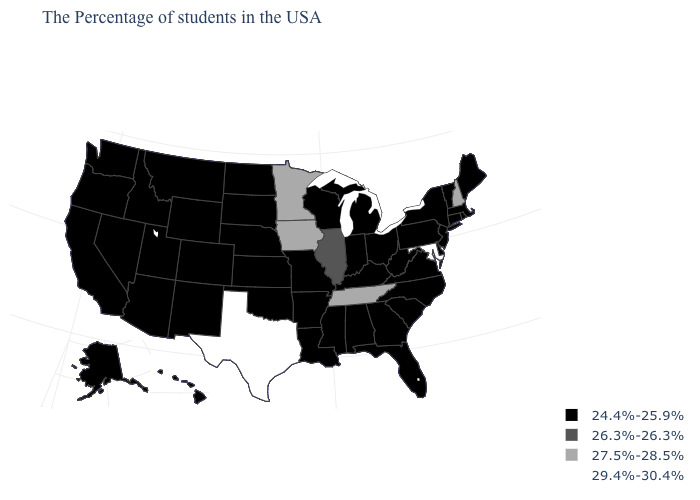Is the legend a continuous bar?
Write a very short answer. No. What is the value of New Hampshire?
Keep it brief. 27.5%-28.5%. What is the value of Illinois?
Short answer required. 26.3%-26.3%. Name the states that have a value in the range 27.5%-28.5%?
Concise answer only. New Hampshire, Tennessee, Minnesota, Iowa. What is the value of New Jersey?
Answer briefly. 24.4%-25.9%. Name the states that have a value in the range 27.5%-28.5%?
Answer briefly. New Hampshire, Tennessee, Minnesota, Iowa. What is the value of Pennsylvania?
Answer briefly. 24.4%-25.9%. Name the states that have a value in the range 27.5%-28.5%?
Answer briefly. New Hampshire, Tennessee, Minnesota, Iowa. Does Kentucky have the highest value in the South?
Answer briefly. No. What is the lowest value in states that border Washington?
Quick response, please. 24.4%-25.9%. What is the lowest value in the USA?
Short answer required. 24.4%-25.9%. Does Texas have the highest value in the USA?
Concise answer only. Yes. Among the states that border Wisconsin , which have the lowest value?
Concise answer only. Michigan. Name the states that have a value in the range 27.5%-28.5%?
Write a very short answer. New Hampshire, Tennessee, Minnesota, Iowa. Name the states that have a value in the range 27.5%-28.5%?
Give a very brief answer. New Hampshire, Tennessee, Minnesota, Iowa. 